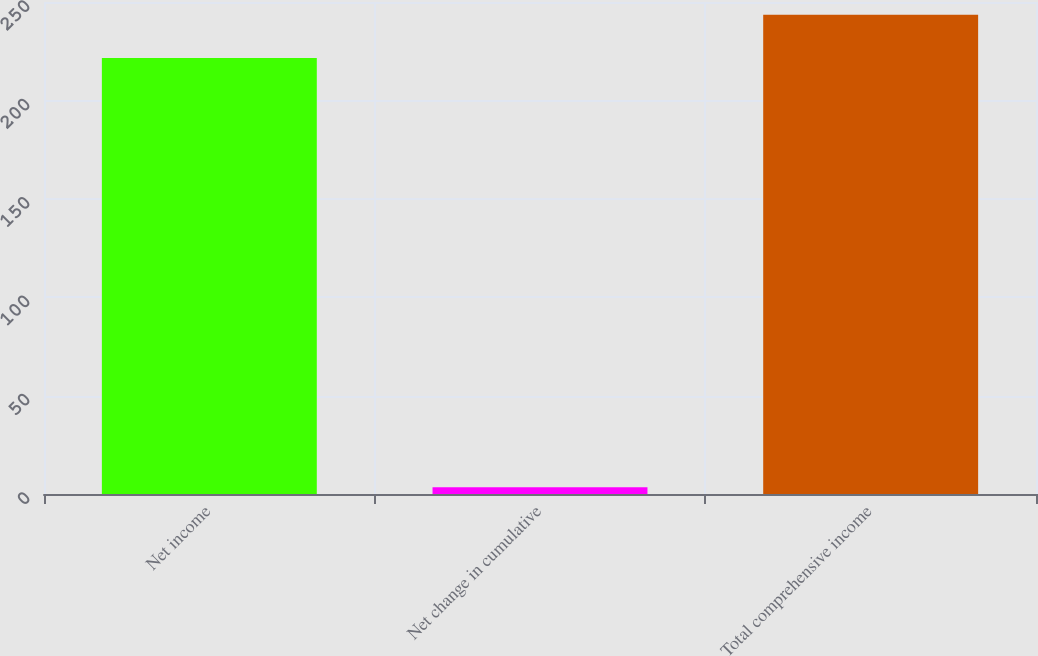Convert chart. <chart><loc_0><loc_0><loc_500><loc_500><bar_chart><fcel>Net income<fcel>Net change in cumulative<fcel>Total comprehensive income<nl><fcel>221.5<fcel>3.4<fcel>243.5<nl></chart> 